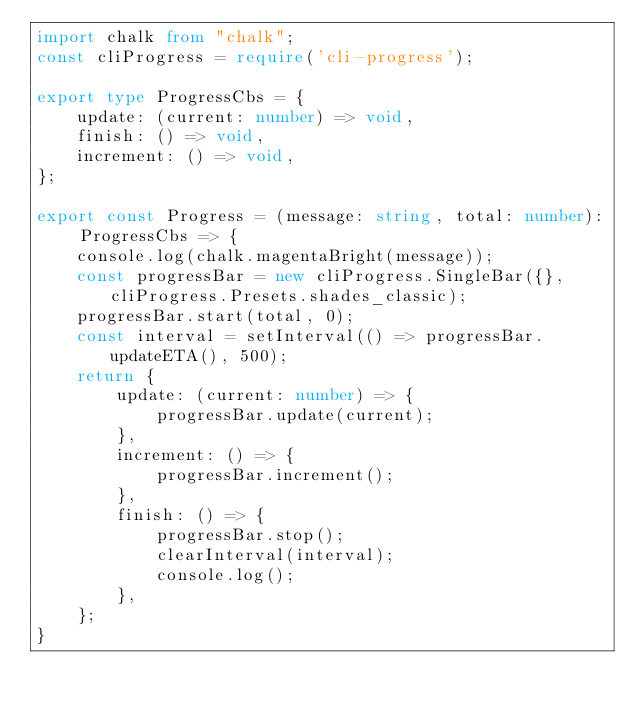<code> <loc_0><loc_0><loc_500><loc_500><_TypeScript_>import chalk from "chalk";
const cliProgress = require('cli-progress');

export type ProgressCbs = {
    update: (current: number) => void,
    finish: () => void,
    increment: () => void,
};

export const Progress = (message: string, total: number): ProgressCbs => {
    console.log(chalk.magentaBright(message));
    const progressBar = new cliProgress.SingleBar({}, cliProgress.Presets.shades_classic);
    progressBar.start(total, 0);
    const interval = setInterval(() => progressBar.updateETA(), 500);
    return {
        update: (current: number) => {
            progressBar.update(current);
        },
        increment: () => {
            progressBar.increment();
        },
        finish: () => {
            progressBar.stop();
            clearInterval(interval);
            console.log();
        },
    };
}
</code> 